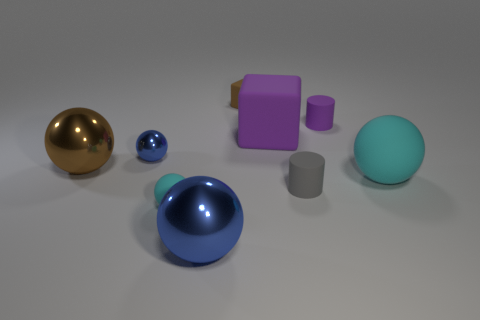Add 1 brown rubber things. How many objects exist? 10 Subtract all cubes. How many objects are left? 7 Add 1 purple blocks. How many purple blocks are left? 2 Add 4 metal balls. How many metal balls exist? 7 Subtract 0 red cylinders. How many objects are left? 9 Subtract all gray spheres. Subtract all small matte balls. How many objects are left? 8 